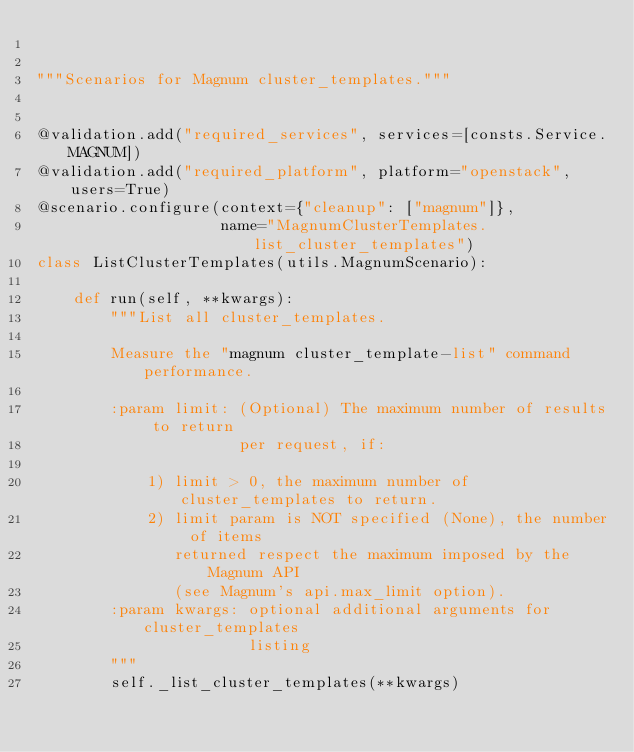Convert code to text. <code><loc_0><loc_0><loc_500><loc_500><_Python_>

"""Scenarios for Magnum cluster_templates."""


@validation.add("required_services", services=[consts.Service.MAGNUM])
@validation.add("required_platform", platform="openstack", users=True)
@scenario.configure(context={"cleanup": ["magnum"]},
                    name="MagnumClusterTemplates.list_cluster_templates")
class ListClusterTemplates(utils.MagnumScenario):

    def run(self, **kwargs):
        """List all cluster_templates.

        Measure the "magnum cluster_template-list" command performance.

        :param limit: (Optional) The maximum number of results to return
                      per request, if:

            1) limit > 0, the maximum number of cluster_templates to return.
            2) limit param is NOT specified (None), the number of items
               returned respect the maximum imposed by the Magnum API
               (see Magnum's api.max_limit option).
        :param kwargs: optional additional arguments for cluster_templates
                       listing
        """
        self._list_cluster_templates(**kwargs)
</code> 